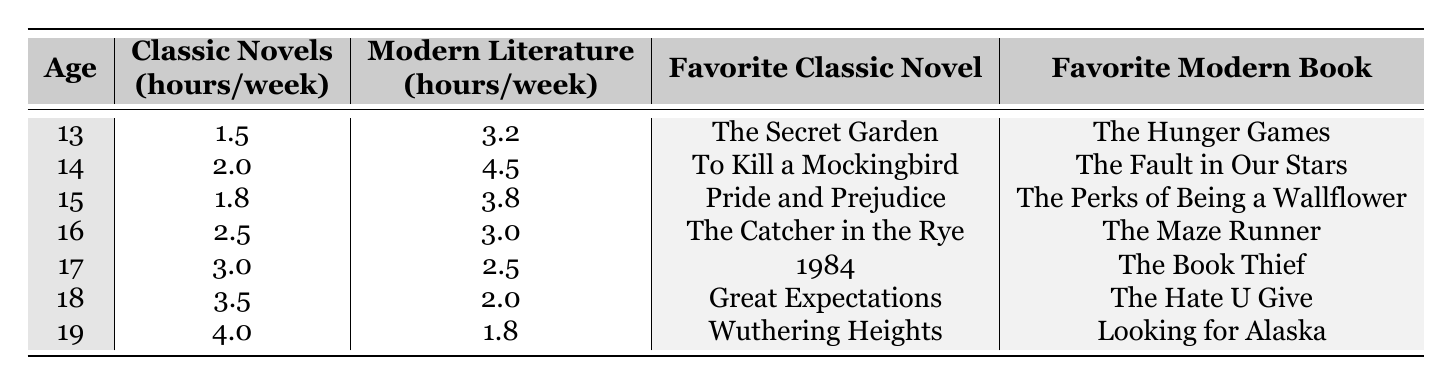What is the total number of hours spent on classic novels by 14 and 17-year-olds combined? For the 14-year-old, the hours spent on classic novels is 2.0, and for the 17-year-old, it is 3.0. Adding these two values gives 2.0 + 3.0 = 5.0 hours.
Answer: 5.0 Which age group spends the most time on classic novels? Looking at the hours spent on classic novels, the youngest age group (13) spends 1.5 hours, while the highest is for the 19-year-old at 4.0 hours. Therefore, 19-year-olds spend the most time.
Answer: 19 Do 15-year-olds spend more time on modern literature than the average of all age groups? The average time spent on modern literature by all age groups is calculated by summing all hours (3.2 + 4.5 + 3.8 + 3.0 + 2.5 + 2.0 + 1.8 = 21.8) and dividing by the number of age groups (7), which equals approximately 3.11. Since 15-year-olds spend 3.8 hours on modern literature, which is more than 3.11, the answer is yes.
Answer: Yes What is the favorite classic novel of the youngest teenager? The youngest teenager is 13 years old, and their favorite classic novel is found in the table under that age, which is "The Secret Garden."
Answer: The Secret Garden Which age group has the greatest difference between hours spent on classic novels and modern literature? The difference for each age group is calculated by subtracting the classic novel hours from modern literature hours; for 19 it is 1.8 - 4.0 = -2.2, and for 17 it is 2.5 - 3.0 = -0.5. The greatest absolute difference is for age 19 (2.2 hours).
Answer: 19 What percentage of their reading time does the 16-year-old dedicate to classic novels? The 16-year-old spends 2.5 hours on classic novels and 3.0 hours on modern literature, making a total reading time of 2.5 + 3.0 = 5.5 hours. The percentage is then calculated as (2.5 / 5.5) * 100 = 45.45%.
Answer: 45.45% Is there a trend showing that older teenagers prefer classic novels more than younger teenagers? By comparing the data, the hours spent on classic novels increase from 1.5 (age 13) to 4.0 (age 19). Hence, it indicates an upward trend as age increases, suggesting older teenagers prefer classic novels.
Answer: Yes 